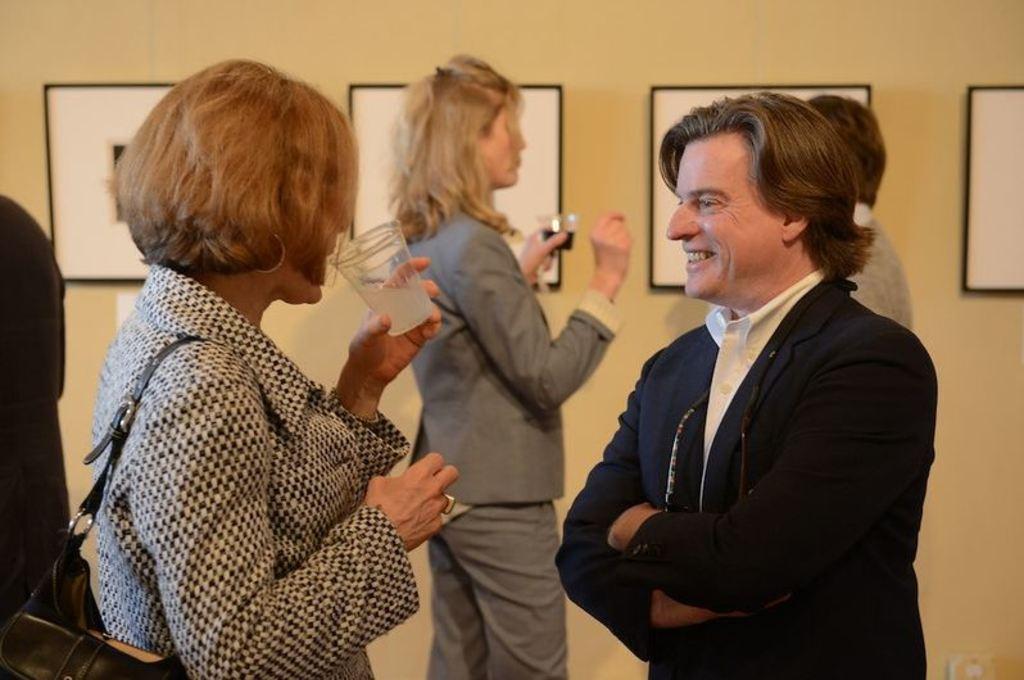Describe this image in one or two sentences. In this image, there are a few people. Among them, some people are holding glasses. We can also see the wall with some posters. 